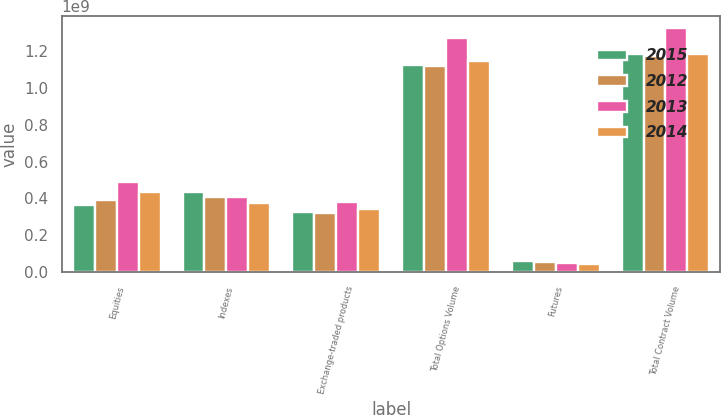<chart> <loc_0><loc_0><loc_500><loc_500><stacked_bar_chart><ecel><fcel>Equities<fcel>Indexes<fcel>Exchange-traded products<fcel>Total Options Volume<fcel>Futures<fcel>Total Contract Volume<nl><fcel>2015<fcel>3.64373e+08<fcel>4.33256e+08<fcel>3.2674e+08<fcel>1.12437e+09<fcel>6.01765e+07<fcel>1.18455e+09<nl><fcel>2012<fcel>3.92982e+08<fcel>4.08282e+08<fcel>3.20997e+08<fcel>1.12226e+09<fcel>5.16712e+07<fcel>1.17393e+09<nl><fcel>2013<fcel>4.88581e+08<fcel>4.06455e+08<fcel>3.79742e+08<fcel>1.27478e+09<fcel>5.06154e+07<fcel>1.32539e+09<nl><fcel>2014<fcel>4.33777e+08<fcel>3.72647e+08<fcel>3.41023e+08<fcel>1.14745e+09<fcel>4.01934e+07<fcel>1.18764e+09<nl></chart> 